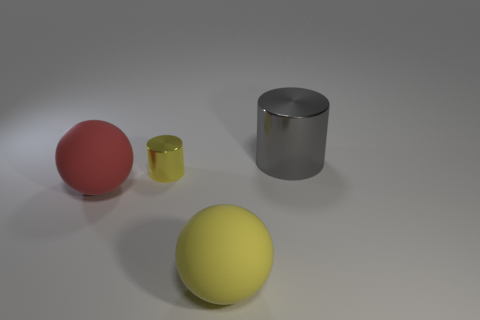Add 3 big yellow spheres. How many objects exist? 7 Add 1 brown rubber balls. How many brown rubber balls exist? 1 Subtract 0 green cubes. How many objects are left? 4 Subtract all big spheres. Subtract all big shiny things. How many objects are left? 1 Add 1 yellow matte balls. How many yellow matte balls are left? 2 